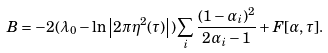Convert formula to latex. <formula><loc_0><loc_0><loc_500><loc_500>B = - 2 ( \lambda _ { 0 } - \ln \left | 2 \pi \eta ^ { 2 } ( \tau ) \right | ) \sum _ { i } \frac { ( 1 - \alpha _ { i } ) ^ { 2 } } { 2 \alpha _ { i } - 1 } + F [ \alpha , \tau ] .</formula> 